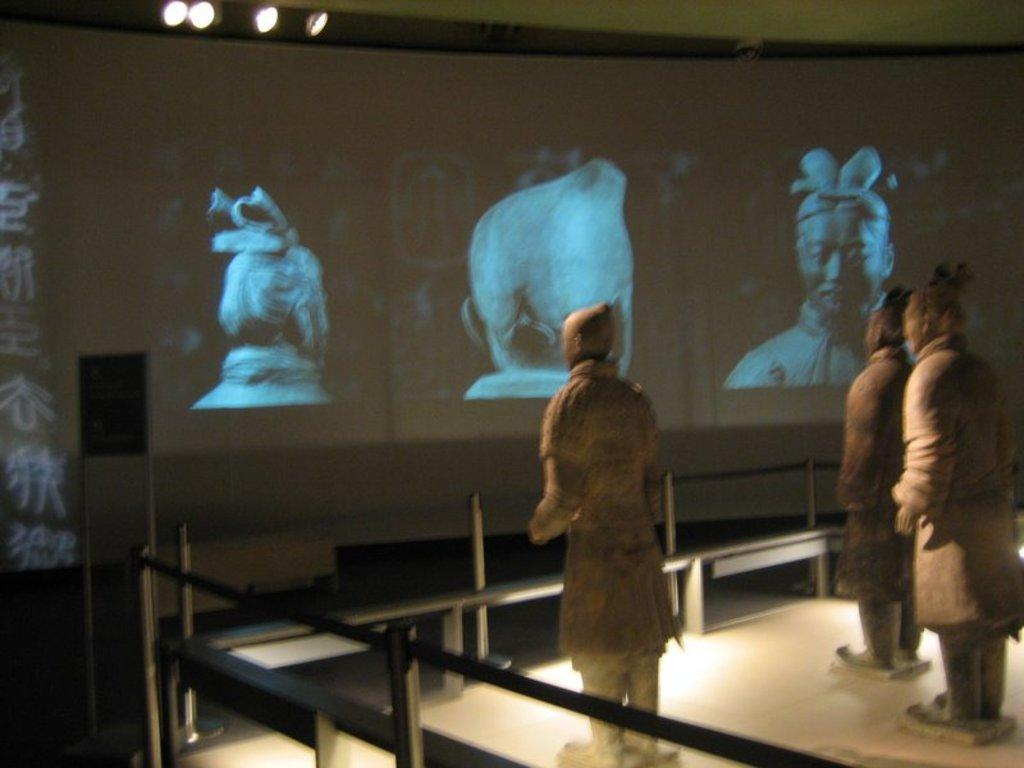What objects are placed on the floor in the image? There are statues on the floor in the image. What separates the statues from the viewer? There are railings in front of the statues. What can be seen in the background of the image? There is a screen with images in the background of the image. What is visible at the top of the image? There are lights visible at the top of the image. What type of weather is depicted in the image? The image does not depict any weather conditions; it features statues, railings, a screen with images, and lights. How does the statue say good-bye to the viewer? The statue is an inanimate object and cannot say good-bye or perform any actions. 